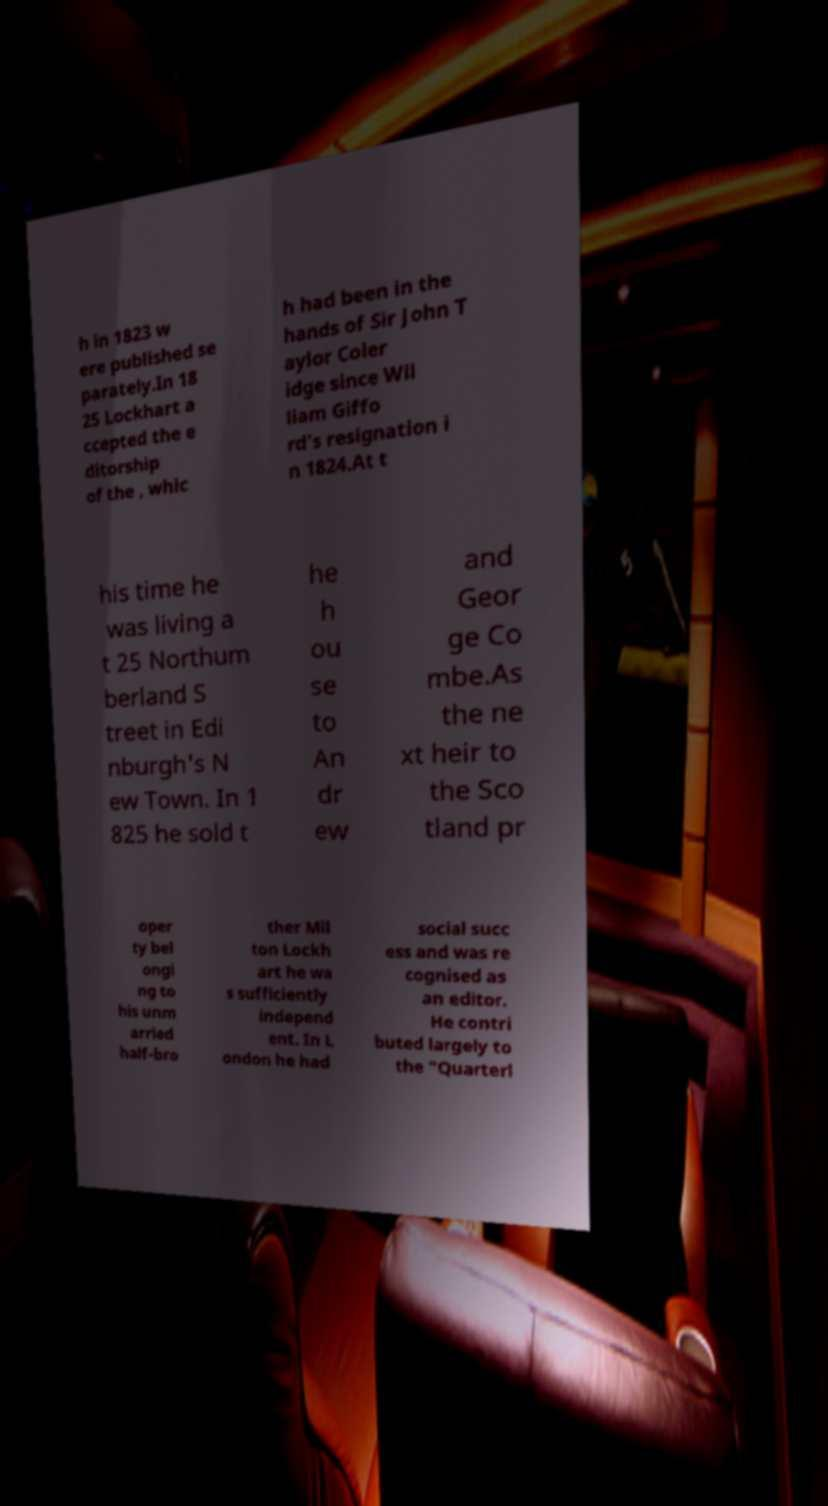Please identify and transcribe the text found in this image. h in 1823 w ere published se parately.In 18 25 Lockhart a ccepted the e ditorship of the , whic h had been in the hands of Sir John T aylor Coler idge since Wil liam Giffo rd's resignation i n 1824.At t his time he was living a t 25 Northum berland S treet in Edi nburgh's N ew Town. In 1 825 he sold t he h ou se to An dr ew and Geor ge Co mbe.As the ne xt heir to the Sco tland pr oper ty bel ongi ng to his unm arried half-bro ther Mil ton Lockh art he wa s sufficiently independ ent. In L ondon he had social succ ess and was re cognised as an editor. He contri buted largely to the "Quarterl 